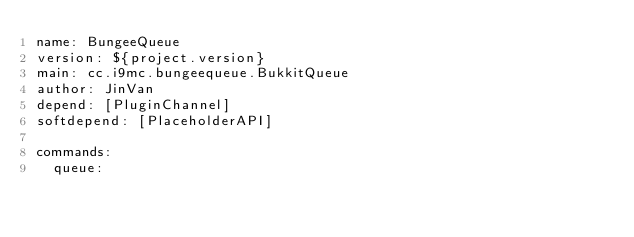<code> <loc_0><loc_0><loc_500><loc_500><_YAML_>name: BungeeQueue
version: ${project.version}
main: cc.i9mc.bungeequeue.BukkitQueue
author: JinVan
depend: [PluginChannel]
softdepend: [PlaceholderAPI]

commands:
  queue:</code> 